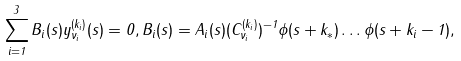<formula> <loc_0><loc_0><loc_500><loc_500>\sum _ { i = 1 } ^ { 3 } B _ { i } ( s ) y _ { \nu _ { i } } ^ { ( k _ { i } ) } ( s ) = 0 , B _ { i } ( s ) = A _ { i } ( s ) ( C _ { \nu _ { i } } ^ { ( k _ { i } ) } ) ^ { - 1 } \phi ( s + k _ { * } ) \dots \phi ( s + k _ { i } - 1 ) ,</formula> 